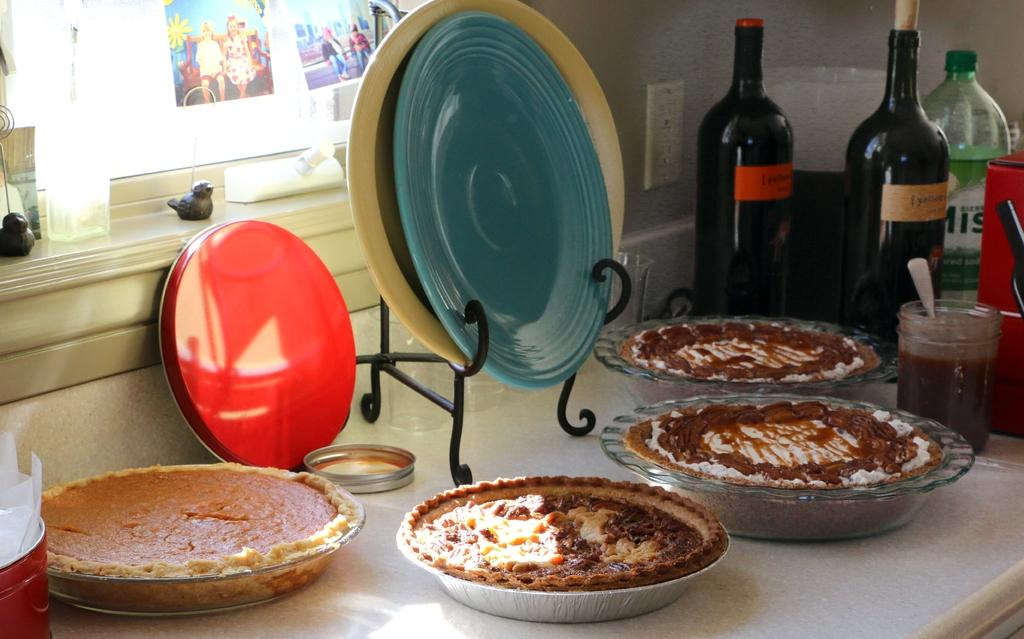What is the primary subject of the image? Food is the main focus of the image. How is the food arranged in the image? The food is presented in bowls. What else can be seen on the stand besides the bowls? There are plates on a stand. What other items are near the bowls? There are bottles, a jar, and a box near the bowls. Where are the photos located in the image? The photos are on a window. What type of wound can be seen on the rat in the image? There is no rat present in the image, and therefore no wound can be observed. 